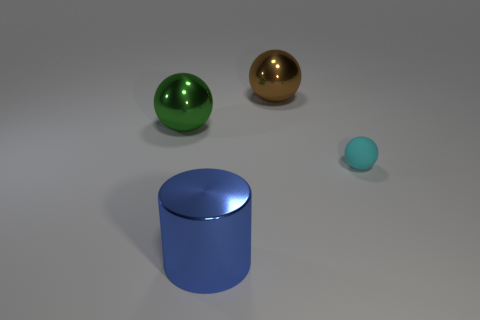Subtract all metallic balls. How many balls are left? 1 Add 1 large brown balls. How many objects exist? 5 Subtract 1 balls. How many balls are left? 2 Subtract all spheres. How many objects are left? 1 Add 1 green things. How many green things exist? 2 Subtract 1 green spheres. How many objects are left? 3 Subtract all big green metal objects. Subtract all big blue cylinders. How many objects are left? 2 Add 3 blue things. How many blue things are left? 4 